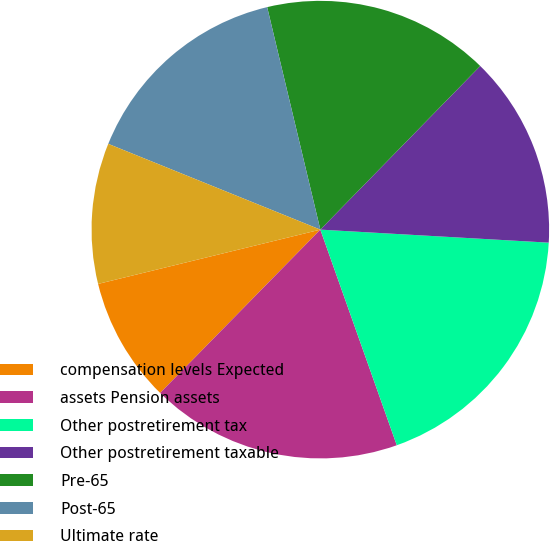Convert chart. <chart><loc_0><loc_0><loc_500><loc_500><pie_chart><fcel>compensation levels Expected<fcel>assets Pension assets<fcel>Other postretirement tax<fcel>Other postretirement taxable<fcel>Pre-65<fcel>Post-65<fcel>Ultimate rate<nl><fcel>8.84%<fcel>17.77%<fcel>18.67%<fcel>13.59%<fcel>16.05%<fcel>15.15%<fcel>9.93%<nl></chart> 